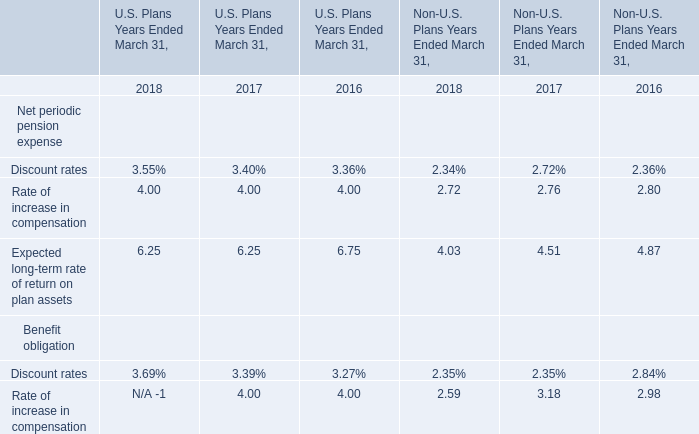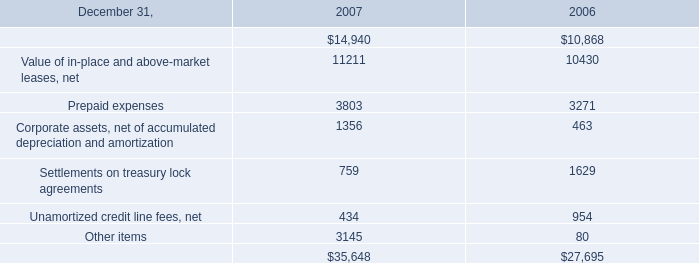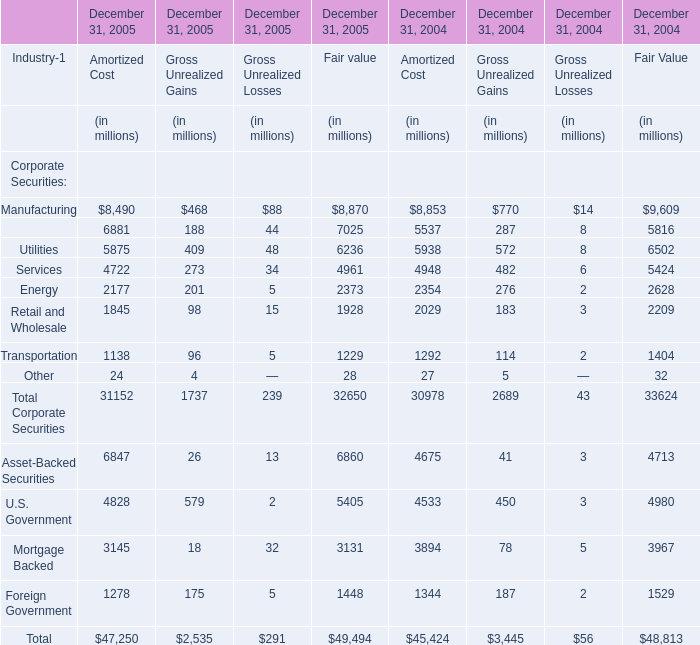Does the value of Manufacturing for Amortized Cost in 2005 greater than that in 2004 ? 
Answer: No. 